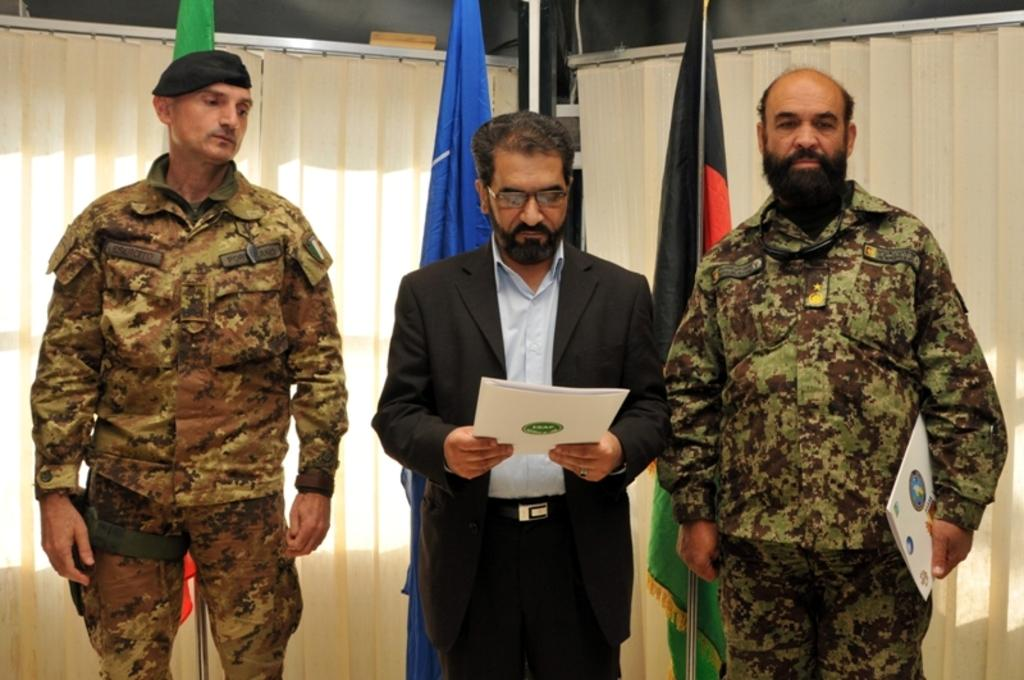How many people are in the image? There are three people in the image. What is one of the people doing in the image? One of the people is holding a book. What can be seen in the background of the image? There are flags and a wall visible in the image. What type of window treatment is present in the image? There are curtains in the image. What type of voice can be heard coming from the people in the image? There is no indication of any voices or sounds in the image, so it's not possible to determine what type of voice might be heard. 